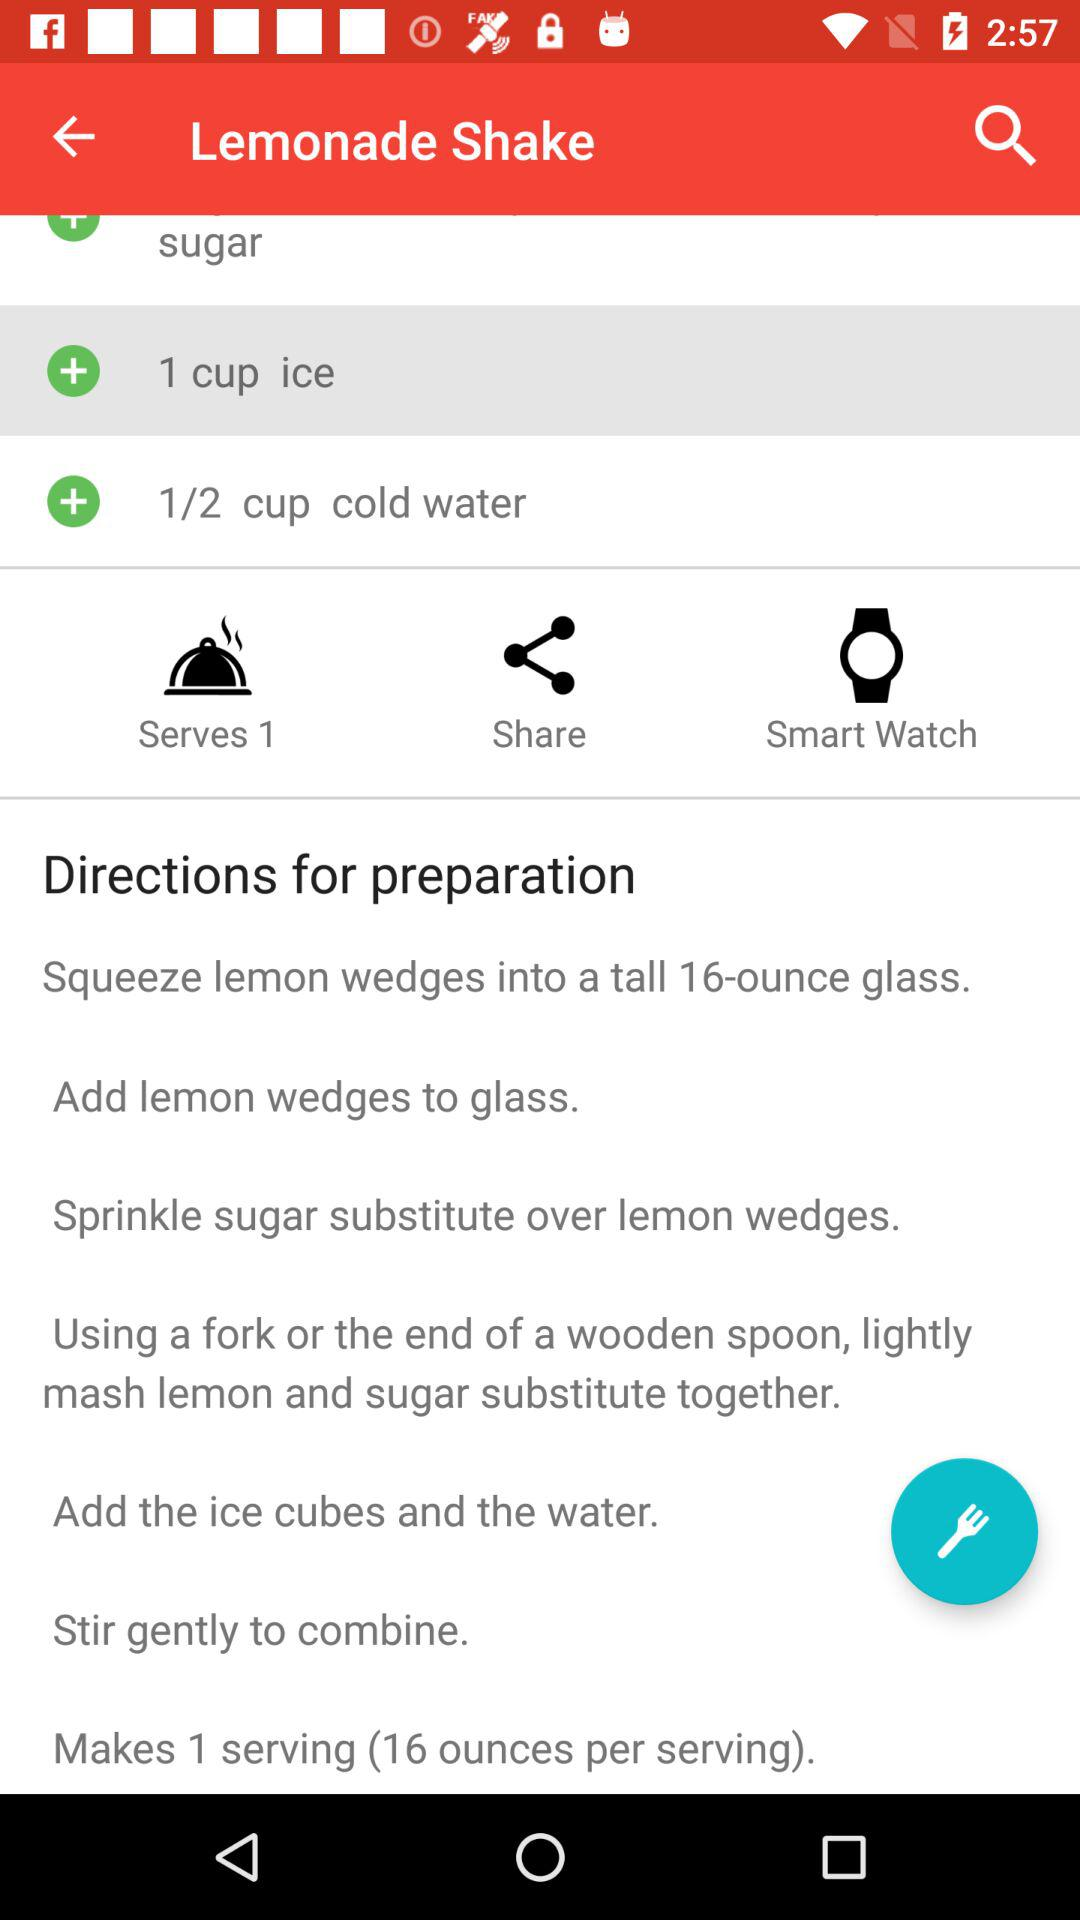How many ounces of liquid are in this recipe?
Answer the question using a single word or phrase. 16 